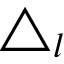Convert formula to latex. <formula><loc_0><loc_0><loc_500><loc_500>\triangle _ { l }</formula> 